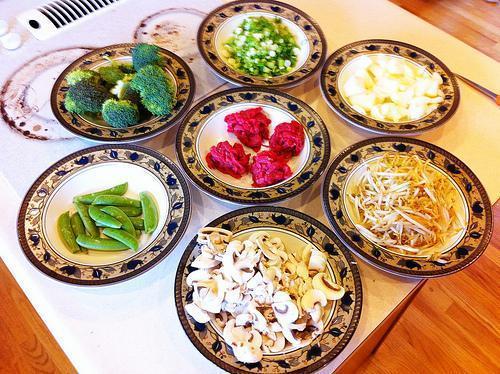How many bowls of food are there?
Give a very brief answer. 7. How many bowls have green food in it?
Give a very brief answer. 3. 